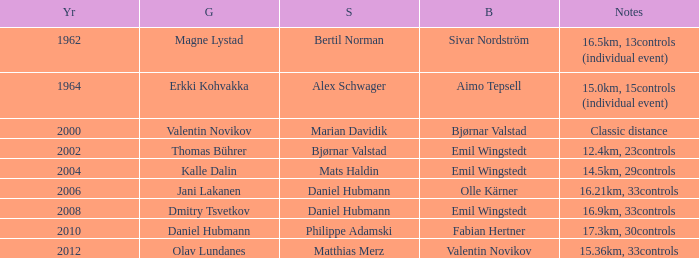WHAT IS THE YEAR WITH A BRONZE OF AIMO TEPSELL? 1964.0. 